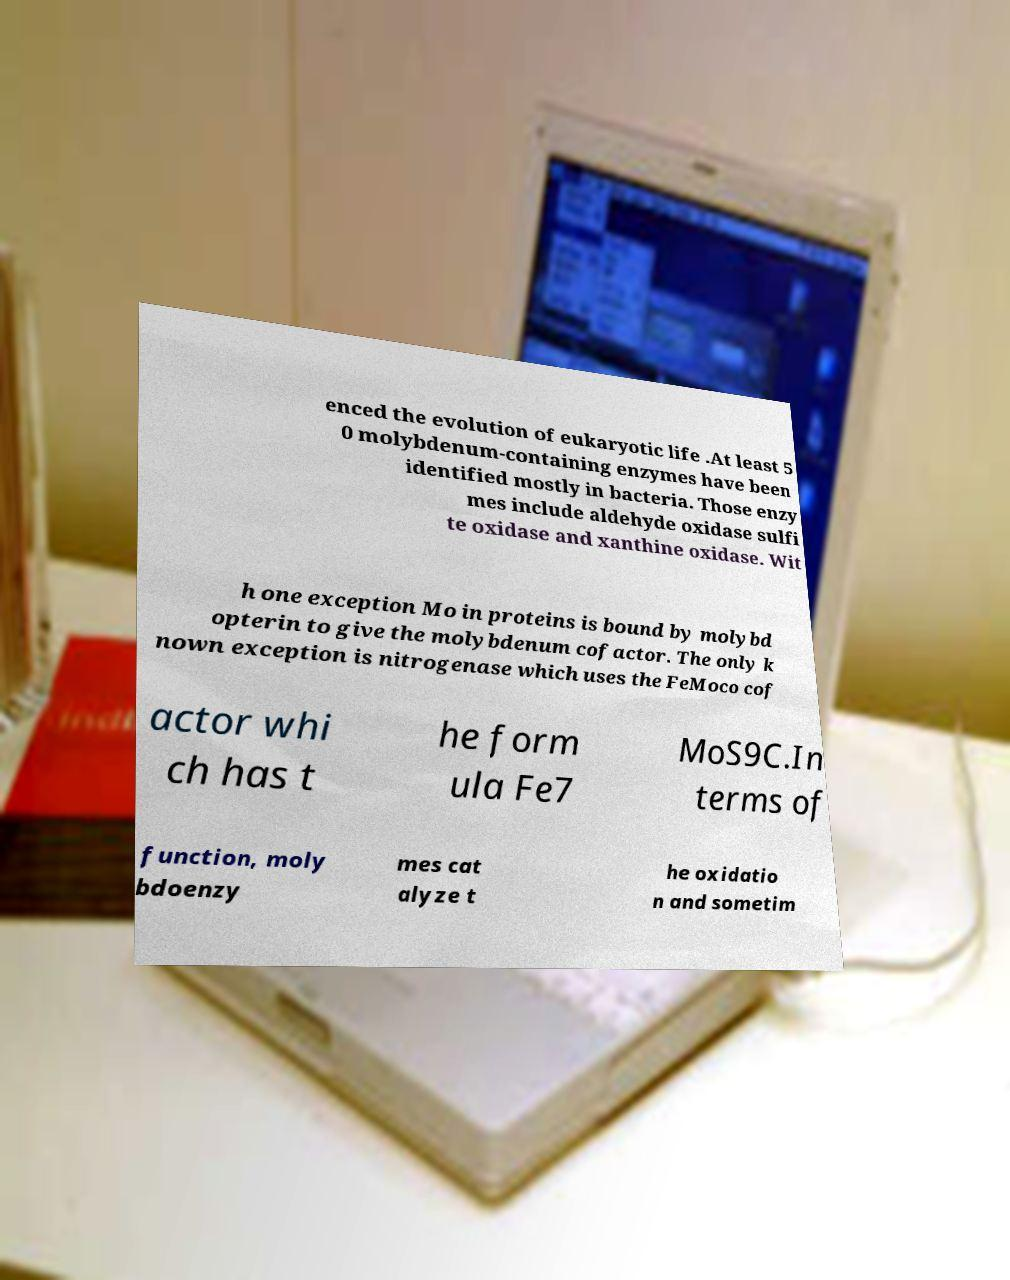Please read and relay the text visible in this image. What does it say? enced the evolution of eukaryotic life .At least 5 0 molybdenum-containing enzymes have been identified mostly in bacteria. Those enzy mes include aldehyde oxidase sulfi te oxidase and xanthine oxidase. Wit h one exception Mo in proteins is bound by molybd opterin to give the molybdenum cofactor. The only k nown exception is nitrogenase which uses the FeMoco cof actor whi ch has t he form ula Fe7 MoS9C.In terms of function, moly bdoenzy mes cat alyze t he oxidatio n and sometim 